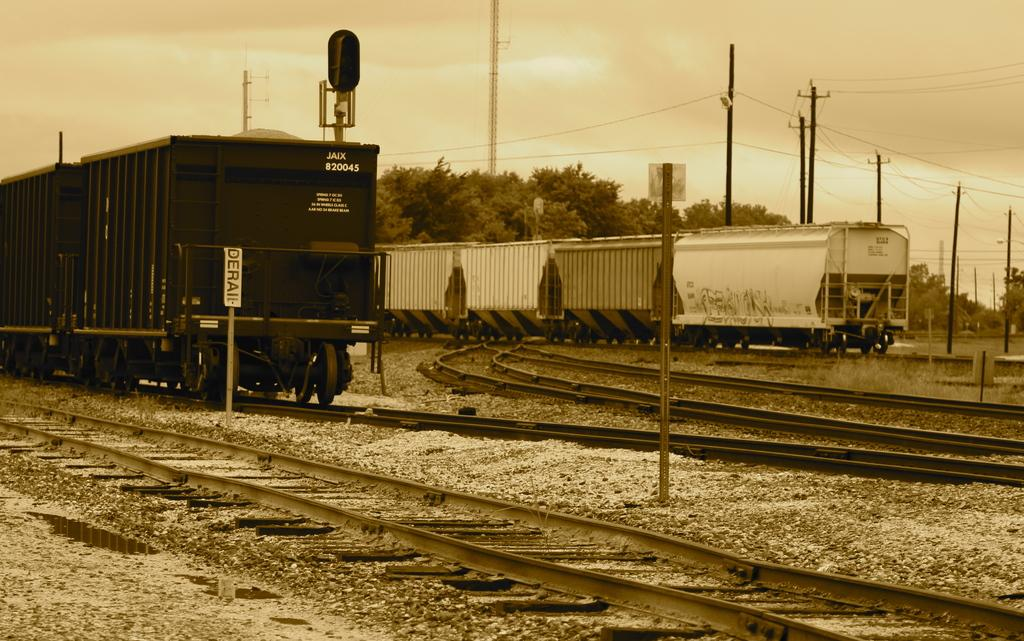What type of vehicles can be seen in the image? There are trains in the image. What is the path that the trains are following? There is a railway track in the image. What type of natural vegetation is present in the image? There are trees in the image. What type of infrastructure is present in the image? There are current poles in the image. What is visible in the background of the image? The sky is visible in the image. What type of band is performing in the image? There is no band present in the image; it features trains, a railway track, trees, current poles, and the sky. How does the pig contribute to the image? There is no pig present in the image. 